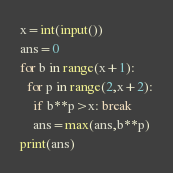<code> <loc_0><loc_0><loc_500><loc_500><_Python_>x=int(input())
ans=0
for b in range(x+1):
  for p in range(2,x+2):
    if b**p>x: break
    ans=max(ans,b**p)
print(ans)
</code> 